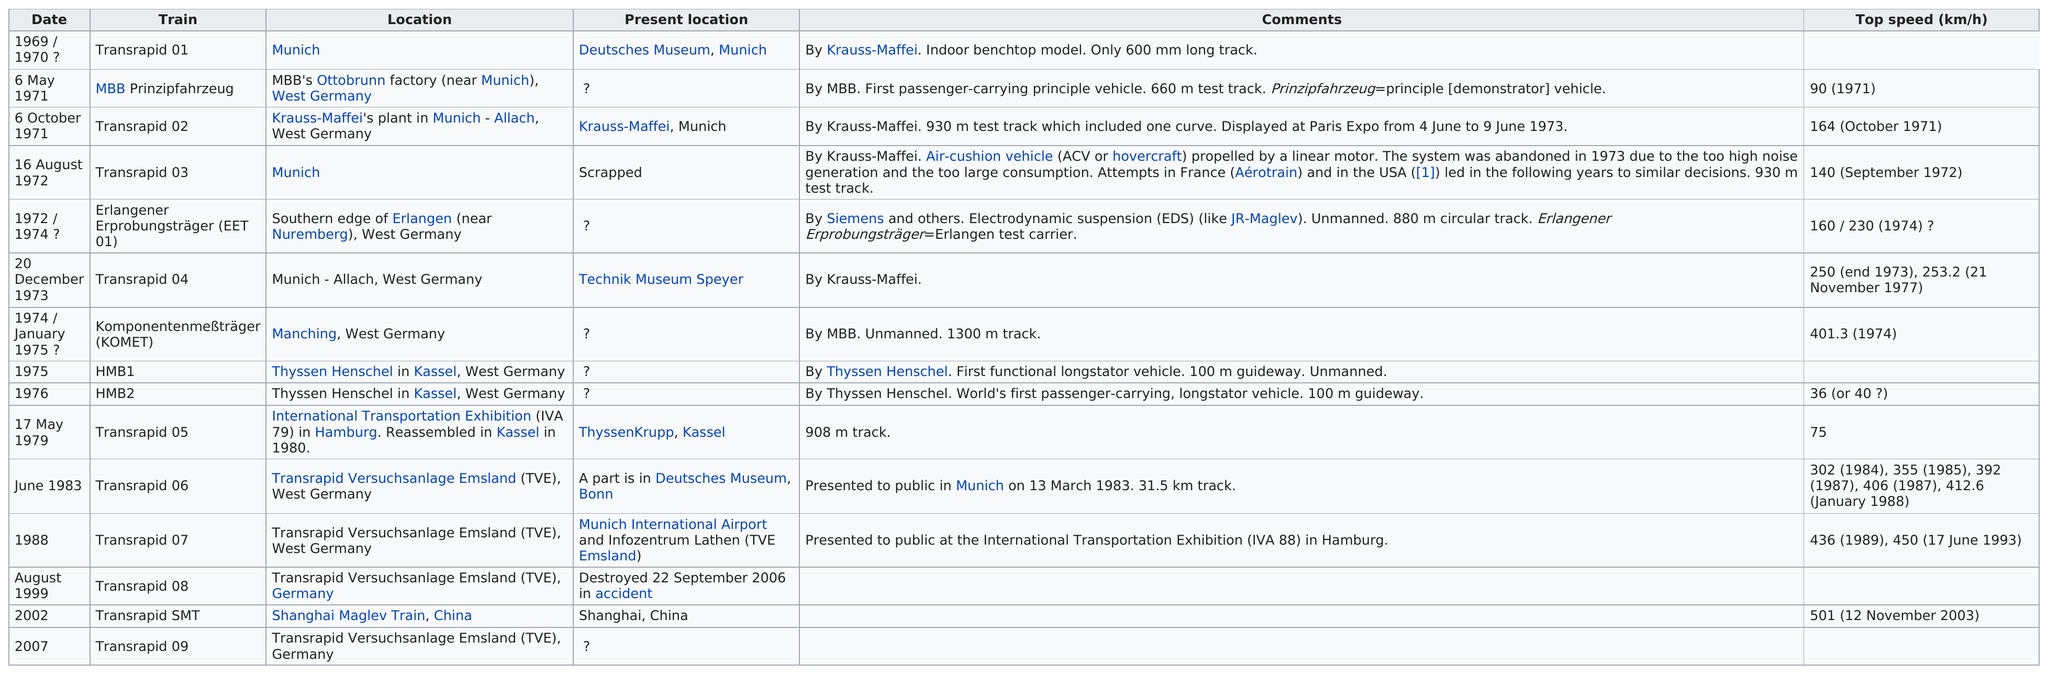Draw attention to some important aspects in this diagram. Please inform me of the number of versions that have been scrapped, from 1 up to... Out of the total number of trains that were scrapped or destroyed, 2 were identified. The Transrapid 07 train had its first public appearance in Hamburg. It is possible for multiple trains, in addition to the Transrapid 07, to travel at speeds exceeding 450 km/h. The Transrapid 03 train was scrapped due to high noise generation and excessive consumption caused by the train. 